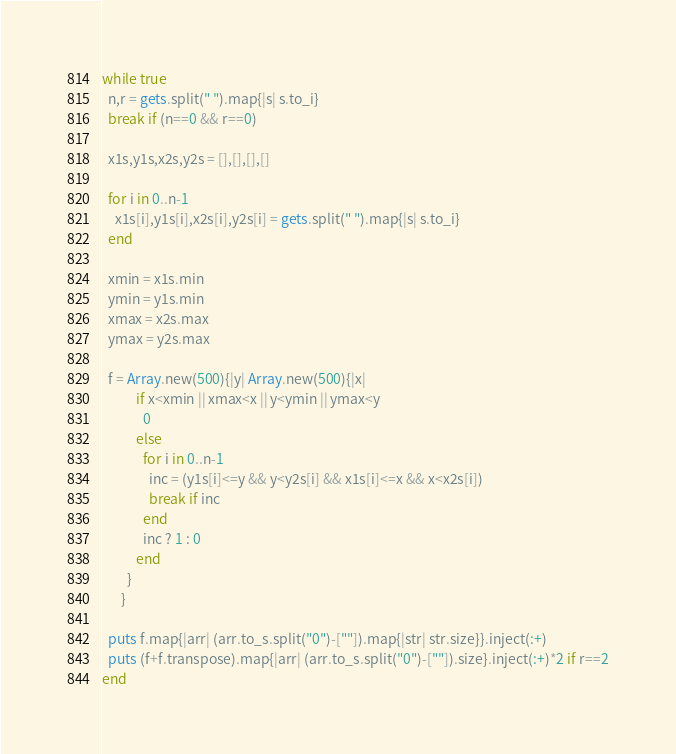<code> <loc_0><loc_0><loc_500><loc_500><_Ruby_>while true
  n,r = gets.split(" ").map{|s| s.to_i}
  break if (n==0 && r==0)
  
  x1s,y1s,x2s,y2s = [],[],[],[]

  for i in 0..n-1
    x1s[i],y1s[i],x2s[i],y2s[i] = gets.split(" ").map{|s| s.to_i}
  end
  
  xmin = x1s.min
  ymin = y1s.min
  xmax = x2s.max
  ymax = y2s.max

  f = Array.new(500){|y| Array.new(500){|x|
           if x<xmin || xmax<x || y<ymin || ymax<y
             0
           else
             for i in 0..n-1
               inc = (y1s[i]<=y && y<y2s[i] && x1s[i]<=x && x<x2s[i])
               break if inc
             end
             inc ? 1 : 0
           end
        }
      }

  puts f.map{|arr| (arr.to_s.split("0")-[""]).map{|str| str.size}}.inject(:+)
  puts (f+f.transpose).map{|arr| (arr.to_s.split("0")-[""]).size}.inject(:+)*2 if r==2
end</code> 